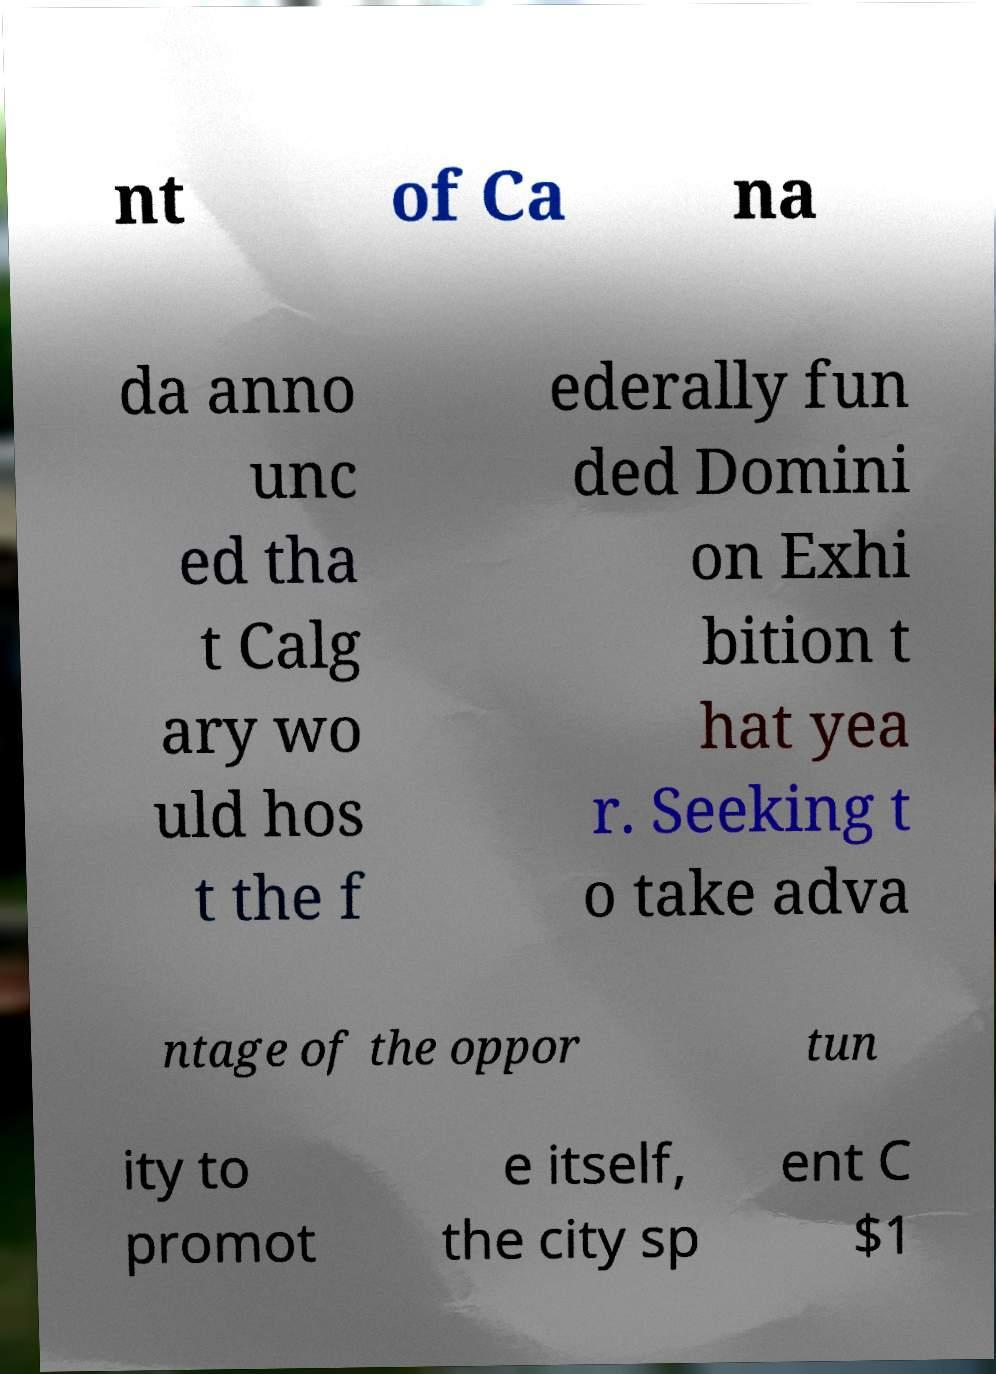Please identify and transcribe the text found in this image. nt of Ca na da anno unc ed tha t Calg ary wo uld hos t the f ederally fun ded Domini on Exhi bition t hat yea r. Seeking t o take adva ntage of the oppor tun ity to promot e itself, the city sp ent C $1 